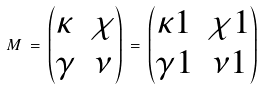<formula> <loc_0><loc_0><loc_500><loc_500>M \, = \, \begin{pmatrix} \kappa & \chi \\ \gamma & \nu \end{pmatrix} \, = \, \begin{pmatrix} \kappa 1 & \chi 1 \\ \gamma 1 & \nu 1 \end{pmatrix}</formula> 